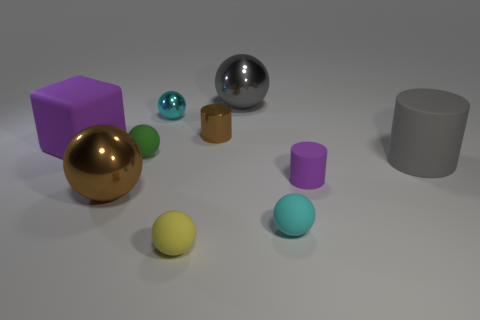What is the shape of the cyan object behind the small brown metallic object?
Your response must be concise. Sphere. There is a large metallic ball that is to the left of the yellow thing; is it the same color as the small cylinder behind the big purple thing?
Keep it short and to the point. Yes. What number of objects are both left of the gray cylinder and right of the small cyan rubber thing?
Your response must be concise. 1. What size is the purple cube that is made of the same material as the gray cylinder?
Ensure brevity in your answer.  Large. How big is the green rubber thing?
Keep it short and to the point. Small. What is the green ball made of?
Offer a terse response. Rubber. Does the cyan sphere that is in front of the cyan metallic sphere have the same size as the tiny green sphere?
Offer a very short reply. Yes. How many objects are gray shiny balls or gray blocks?
Provide a succinct answer. 1. What is the shape of the big shiny object that is the same color as the big matte cylinder?
Your answer should be very brief. Sphere. There is a matte sphere that is in front of the green ball and behind the tiny yellow matte ball; how big is it?
Offer a terse response. Small. 